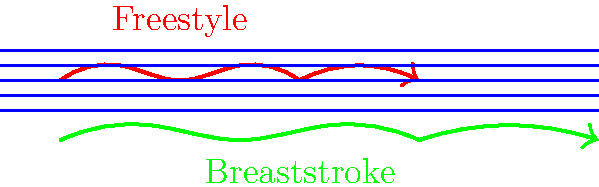As a CyberSecurity Specialist with experience in code review, you're tasked with analyzing the efficiency of different swimming strokes based on fluid dynamics principles. Given the streamlined body outlines and fluid dynamics indicators in the diagram, which stroke appears to be more efficient and why? To analyze the efficiency of the swimming strokes, we need to consider the following factors:

1. Streamline shape: A more streamlined body position reduces drag in the water.
2. Fluid flow: Smoother fluid lines around the swimmer indicate less turbulence and better efficiency.
3. Forward propulsion: The direction and length of the arrow indicate the effectiveness of forward motion.

Step-by-step analysis:

1. Freestyle (red):
   - Body position is more horizontal, creating a streamlined shape.
   - Fluid lines around the swimmer are less disturbed, indicating smoother flow.
   - The arrow shows a longer, more direct forward motion.

2. Breaststroke (green):
   - Body position is less horizontal, creating more frontal drag.
   - Fluid lines show more disturbance, indicating increased turbulence.
   - The arrow shows a shorter, less direct forward motion.

3. Efficiency comparison:
   - Freestyle demonstrates better streamlining, reduced turbulence, and more effective forward propulsion.
   - Breaststroke shows more body movement, increased turbulence, and less efficient forward motion.

4. Relation to coding principles:
   - Just as efficient code minimizes unnecessary operations and optimizes resource usage, an efficient swimming stroke minimizes energy expenditure and maximizes forward propulsion.
   - The freestyle stroke, like well-optimized code, achieves its goal (forward motion) with less "overhead" (energy loss due to drag and turbulence).

Based on these observations and principles of fluid dynamics, the freestyle stroke appears to be more efficient in this comparison.
Answer: Freestyle, due to better streamlining, reduced turbulence, and more effective forward propulsion. 